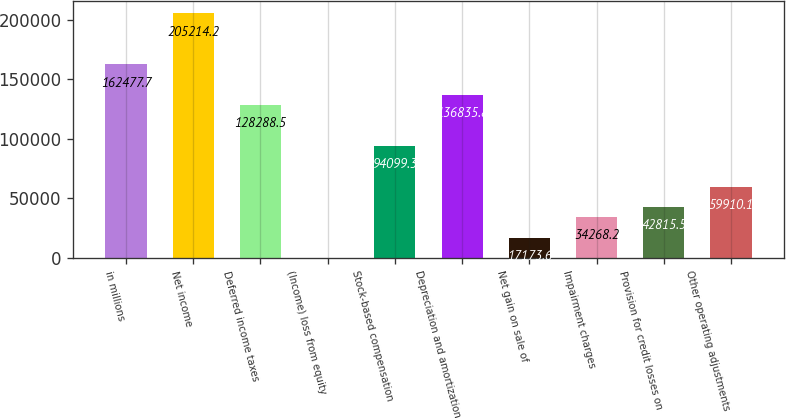Convert chart to OTSL. <chart><loc_0><loc_0><loc_500><loc_500><bar_chart><fcel>in millions<fcel>Net income<fcel>Deferred income taxes<fcel>(Income) loss from equity<fcel>Stock-based compensation<fcel>Depreciation and amortization<fcel>Net gain on sale of<fcel>Impairment charges<fcel>Provision for credit losses on<fcel>Other operating adjustments<nl><fcel>162478<fcel>205214<fcel>128288<fcel>79<fcel>94099.3<fcel>136836<fcel>17173.6<fcel>34268.2<fcel>42815.5<fcel>59910.1<nl></chart> 